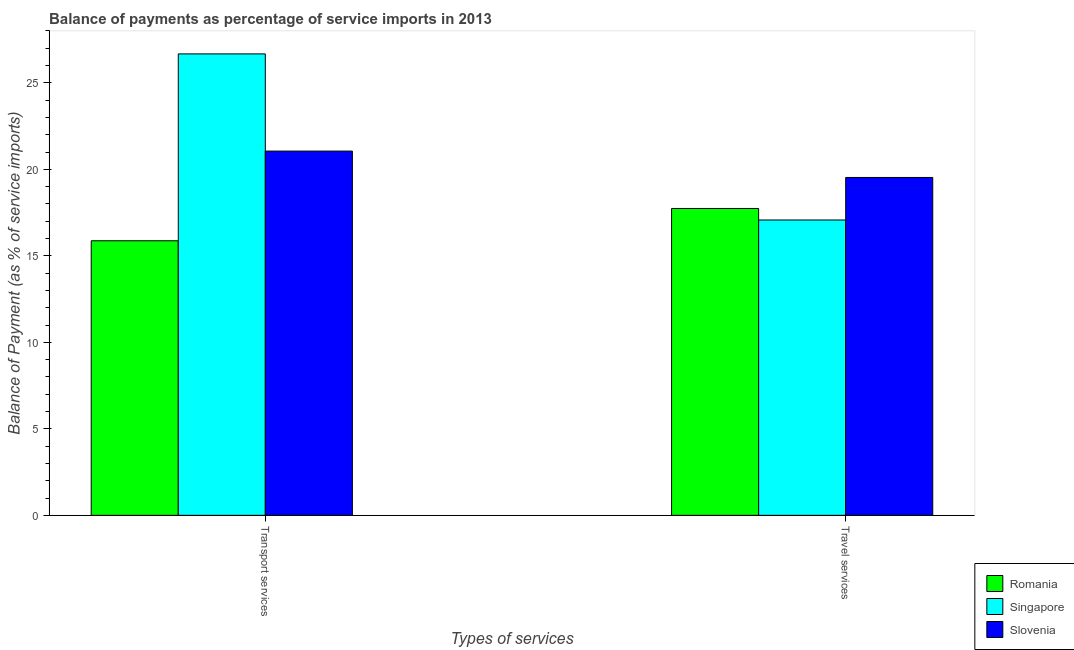How many different coloured bars are there?
Your answer should be very brief. 3. How many groups of bars are there?
Offer a very short reply. 2. Are the number of bars per tick equal to the number of legend labels?
Provide a succinct answer. Yes. How many bars are there on the 1st tick from the right?
Make the answer very short. 3. What is the label of the 1st group of bars from the left?
Provide a short and direct response. Transport services. What is the balance of payments of travel services in Romania?
Give a very brief answer. 17.74. Across all countries, what is the maximum balance of payments of travel services?
Your response must be concise. 19.53. Across all countries, what is the minimum balance of payments of transport services?
Make the answer very short. 15.87. In which country was the balance of payments of travel services maximum?
Keep it short and to the point. Slovenia. In which country was the balance of payments of transport services minimum?
Keep it short and to the point. Romania. What is the total balance of payments of transport services in the graph?
Provide a succinct answer. 63.6. What is the difference between the balance of payments of transport services in Romania and that in Slovenia?
Offer a terse response. -5.18. What is the difference between the balance of payments of transport services in Slovenia and the balance of payments of travel services in Singapore?
Keep it short and to the point. 3.98. What is the average balance of payments of transport services per country?
Give a very brief answer. 21.2. What is the difference between the balance of payments of travel services and balance of payments of transport services in Slovenia?
Offer a very short reply. -1.52. In how many countries, is the balance of payments of travel services greater than 8 %?
Give a very brief answer. 3. What is the ratio of the balance of payments of travel services in Slovenia to that in Singapore?
Your response must be concise. 1.14. What does the 1st bar from the left in Transport services represents?
Ensure brevity in your answer.  Romania. What does the 3rd bar from the right in Travel services represents?
Make the answer very short. Romania. How many bars are there?
Give a very brief answer. 6. How many countries are there in the graph?
Offer a very short reply. 3. Are the values on the major ticks of Y-axis written in scientific E-notation?
Provide a short and direct response. No. How are the legend labels stacked?
Ensure brevity in your answer.  Vertical. What is the title of the graph?
Offer a terse response. Balance of payments as percentage of service imports in 2013. What is the label or title of the X-axis?
Offer a very short reply. Types of services. What is the label or title of the Y-axis?
Give a very brief answer. Balance of Payment (as % of service imports). What is the Balance of Payment (as % of service imports) of Romania in Transport services?
Offer a terse response. 15.87. What is the Balance of Payment (as % of service imports) in Singapore in Transport services?
Your response must be concise. 26.67. What is the Balance of Payment (as % of service imports) in Slovenia in Transport services?
Provide a short and direct response. 21.05. What is the Balance of Payment (as % of service imports) in Romania in Travel services?
Keep it short and to the point. 17.74. What is the Balance of Payment (as % of service imports) of Singapore in Travel services?
Your answer should be compact. 17.07. What is the Balance of Payment (as % of service imports) of Slovenia in Travel services?
Provide a succinct answer. 19.53. Across all Types of services, what is the maximum Balance of Payment (as % of service imports) in Romania?
Ensure brevity in your answer.  17.74. Across all Types of services, what is the maximum Balance of Payment (as % of service imports) of Singapore?
Your response must be concise. 26.67. Across all Types of services, what is the maximum Balance of Payment (as % of service imports) of Slovenia?
Make the answer very short. 21.05. Across all Types of services, what is the minimum Balance of Payment (as % of service imports) in Romania?
Provide a short and direct response. 15.87. Across all Types of services, what is the minimum Balance of Payment (as % of service imports) in Singapore?
Your answer should be compact. 17.07. Across all Types of services, what is the minimum Balance of Payment (as % of service imports) of Slovenia?
Make the answer very short. 19.53. What is the total Balance of Payment (as % of service imports) of Romania in the graph?
Offer a very short reply. 33.61. What is the total Balance of Payment (as % of service imports) in Singapore in the graph?
Offer a very short reply. 43.74. What is the total Balance of Payment (as % of service imports) in Slovenia in the graph?
Give a very brief answer. 40.59. What is the difference between the Balance of Payment (as % of service imports) in Romania in Transport services and that in Travel services?
Offer a terse response. -1.87. What is the difference between the Balance of Payment (as % of service imports) of Singapore in Transport services and that in Travel services?
Keep it short and to the point. 9.6. What is the difference between the Balance of Payment (as % of service imports) of Slovenia in Transport services and that in Travel services?
Give a very brief answer. 1.52. What is the difference between the Balance of Payment (as % of service imports) of Romania in Transport services and the Balance of Payment (as % of service imports) of Singapore in Travel services?
Offer a very short reply. -1.2. What is the difference between the Balance of Payment (as % of service imports) in Romania in Transport services and the Balance of Payment (as % of service imports) in Slovenia in Travel services?
Make the answer very short. -3.66. What is the difference between the Balance of Payment (as % of service imports) in Singapore in Transport services and the Balance of Payment (as % of service imports) in Slovenia in Travel services?
Make the answer very short. 7.14. What is the average Balance of Payment (as % of service imports) in Romania per Types of services?
Your response must be concise. 16.8. What is the average Balance of Payment (as % of service imports) of Singapore per Types of services?
Your answer should be compact. 21.87. What is the average Balance of Payment (as % of service imports) of Slovenia per Types of services?
Provide a short and direct response. 20.29. What is the difference between the Balance of Payment (as % of service imports) in Romania and Balance of Payment (as % of service imports) in Singapore in Transport services?
Offer a terse response. -10.8. What is the difference between the Balance of Payment (as % of service imports) of Romania and Balance of Payment (as % of service imports) of Slovenia in Transport services?
Give a very brief answer. -5.18. What is the difference between the Balance of Payment (as % of service imports) in Singapore and Balance of Payment (as % of service imports) in Slovenia in Transport services?
Provide a succinct answer. 5.62. What is the difference between the Balance of Payment (as % of service imports) of Romania and Balance of Payment (as % of service imports) of Singapore in Travel services?
Make the answer very short. 0.67. What is the difference between the Balance of Payment (as % of service imports) in Romania and Balance of Payment (as % of service imports) in Slovenia in Travel services?
Ensure brevity in your answer.  -1.79. What is the difference between the Balance of Payment (as % of service imports) in Singapore and Balance of Payment (as % of service imports) in Slovenia in Travel services?
Your answer should be very brief. -2.46. What is the ratio of the Balance of Payment (as % of service imports) in Romania in Transport services to that in Travel services?
Your answer should be compact. 0.89. What is the ratio of the Balance of Payment (as % of service imports) of Singapore in Transport services to that in Travel services?
Your answer should be very brief. 1.56. What is the ratio of the Balance of Payment (as % of service imports) of Slovenia in Transport services to that in Travel services?
Keep it short and to the point. 1.08. What is the difference between the highest and the second highest Balance of Payment (as % of service imports) in Romania?
Your response must be concise. 1.87. What is the difference between the highest and the second highest Balance of Payment (as % of service imports) in Singapore?
Offer a terse response. 9.6. What is the difference between the highest and the second highest Balance of Payment (as % of service imports) of Slovenia?
Offer a very short reply. 1.52. What is the difference between the highest and the lowest Balance of Payment (as % of service imports) of Romania?
Your answer should be very brief. 1.87. What is the difference between the highest and the lowest Balance of Payment (as % of service imports) in Singapore?
Offer a very short reply. 9.6. What is the difference between the highest and the lowest Balance of Payment (as % of service imports) of Slovenia?
Make the answer very short. 1.52. 